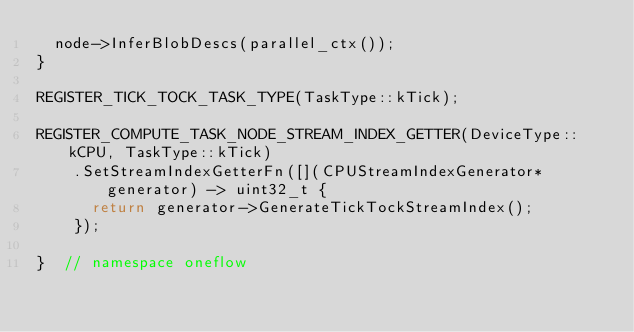Convert code to text. <code><loc_0><loc_0><loc_500><loc_500><_C++_>  node->InferBlobDescs(parallel_ctx());
}

REGISTER_TICK_TOCK_TASK_TYPE(TaskType::kTick);

REGISTER_COMPUTE_TASK_NODE_STREAM_INDEX_GETTER(DeviceType::kCPU, TaskType::kTick)
    .SetStreamIndexGetterFn([](CPUStreamIndexGenerator* generator) -> uint32_t {
      return generator->GenerateTickTockStreamIndex();
    });

}  // namespace oneflow
</code> 